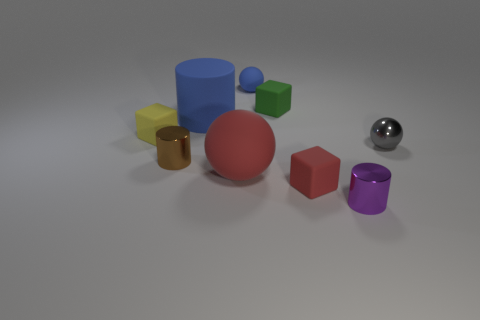Is the number of small balls that are in front of the tiny green matte thing greater than the number of large cylinders that are in front of the large red matte ball? After closely examining the image, it appears that there are two small balls in front of the tiny green matte object. In comparison, there are no large cylinders in front of the large red matte ball. Thus, the number of small balls in front of the tiny green object is indeed greater because there are two small balls versus zero large cylinders in the respective locations. 